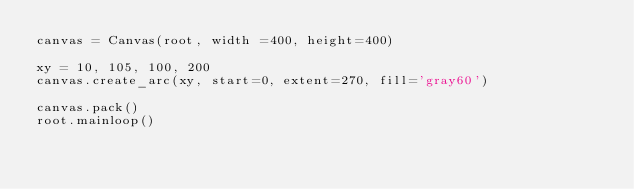Convert code to text. <code><loc_0><loc_0><loc_500><loc_500><_Python_>canvas = Canvas(root, width =400, height=400)

xy = 10, 105, 100, 200
canvas.create_arc(xy, start=0, extent=270, fill='gray60')

canvas.pack()
root.mainloop()</code> 